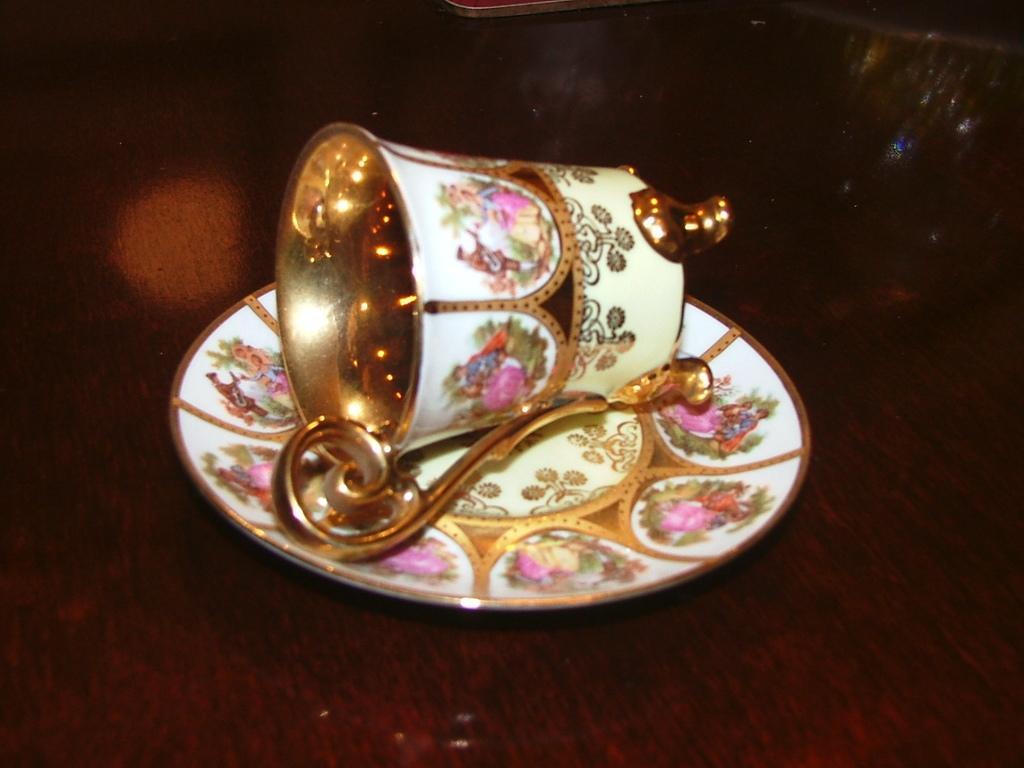In one or two sentences, can you explain what this image depicts? In this image we can see a cup and a saucer placed on a table. 